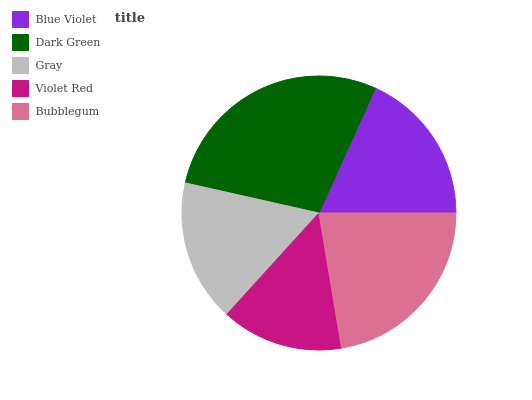Is Violet Red the minimum?
Answer yes or no. Yes. Is Dark Green the maximum?
Answer yes or no. Yes. Is Gray the minimum?
Answer yes or no. No. Is Gray the maximum?
Answer yes or no. No. Is Dark Green greater than Gray?
Answer yes or no. Yes. Is Gray less than Dark Green?
Answer yes or no. Yes. Is Gray greater than Dark Green?
Answer yes or no. No. Is Dark Green less than Gray?
Answer yes or no. No. Is Blue Violet the high median?
Answer yes or no. Yes. Is Blue Violet the low median?
Answer yes or no. Yes. Is Violet Red the high median?
Answer yes or no. No. Is Violet Red the low median?
Answer yes or no. No. 